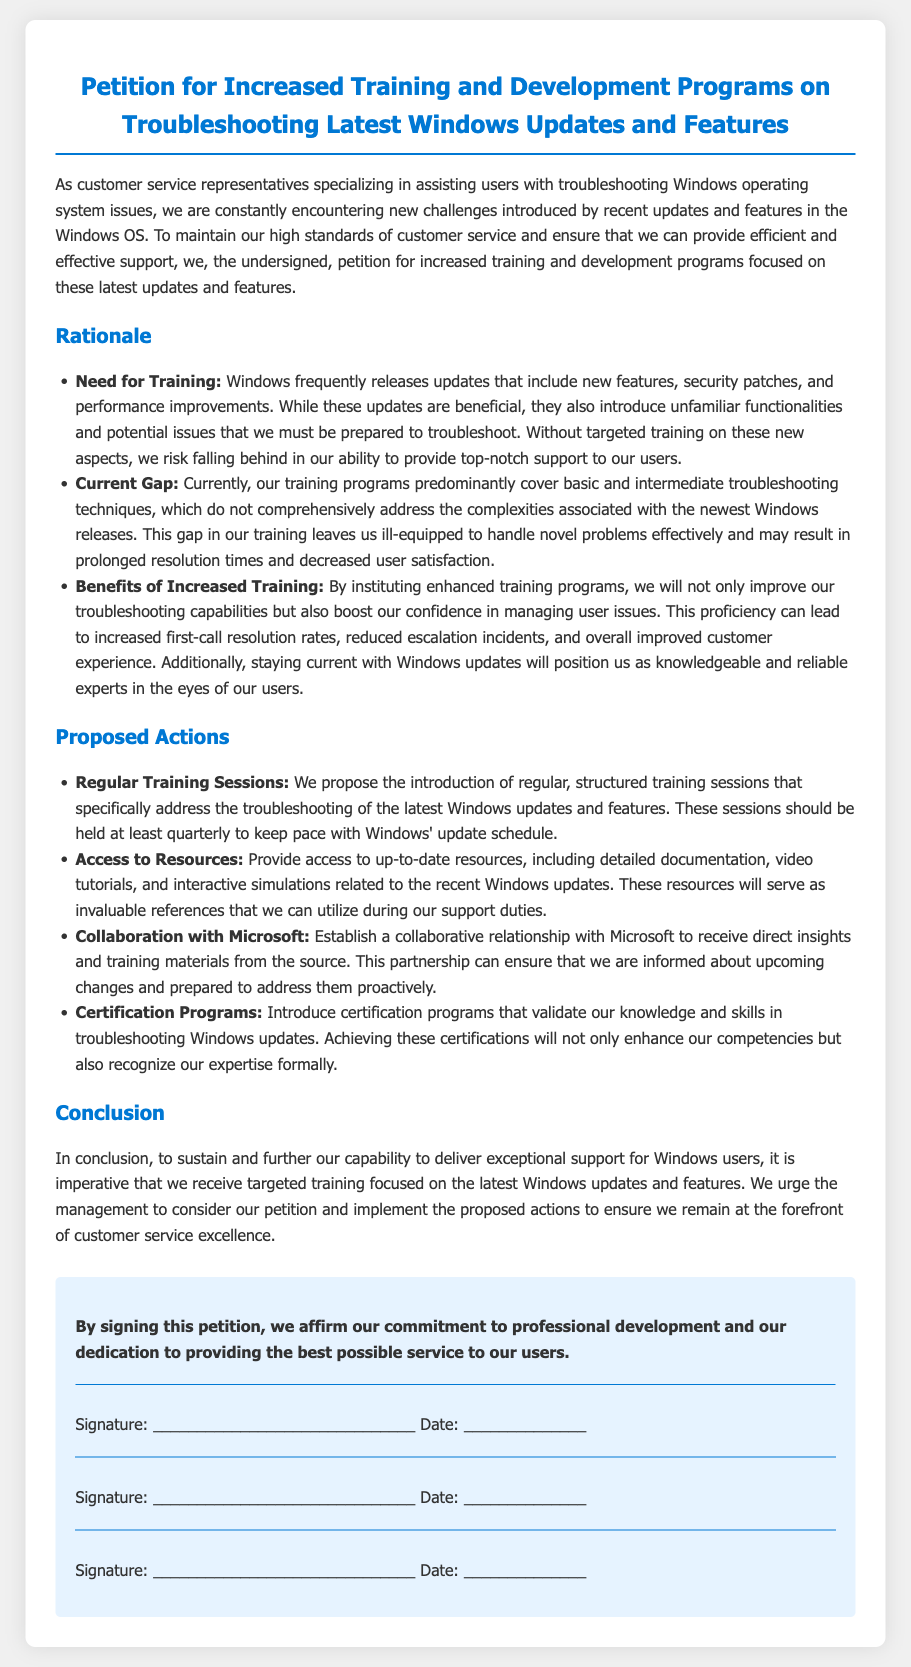What is the title of the petition? The title of the petition is stated at the top of the document.
Answer: Petition for Increased Training and Development Programs on Troubleshooting Latest Windows Updates and Features How many main proposals are included in the document? The document lists a section titled "Proposed Actions" which outlines specific proposals.
Answer: Four What is the proposed frequency of the training sessions? The document specifies how often the training sessions should be held in the proposed actions section.
Answer: Quarterly Who is the intended target audience for this petition? The opening paragraph indicates who the petition is aimed at supporting and serving.
Answer: Customer service representatives What is one benefit of increased training mentioned in the document? The rationale section highlights the benefits associated with enhanced training programs.
Answer: Improved troubleshooting capabilities What is a proposed action involving Microsoft? The document discusses a collaborative relationship aimed at improving training and insights.
Answer: Collaboration with Microsoft What is the purpose of the signature section? The signature section is designed for individuals to affirm their commitment to the petition.
Answer: Commitment to professional development What specific type of programs does the petition propose to introduce? The document refers to a certain type of programs in the proposed actions related to skills validation.
Answer: Certification programs 